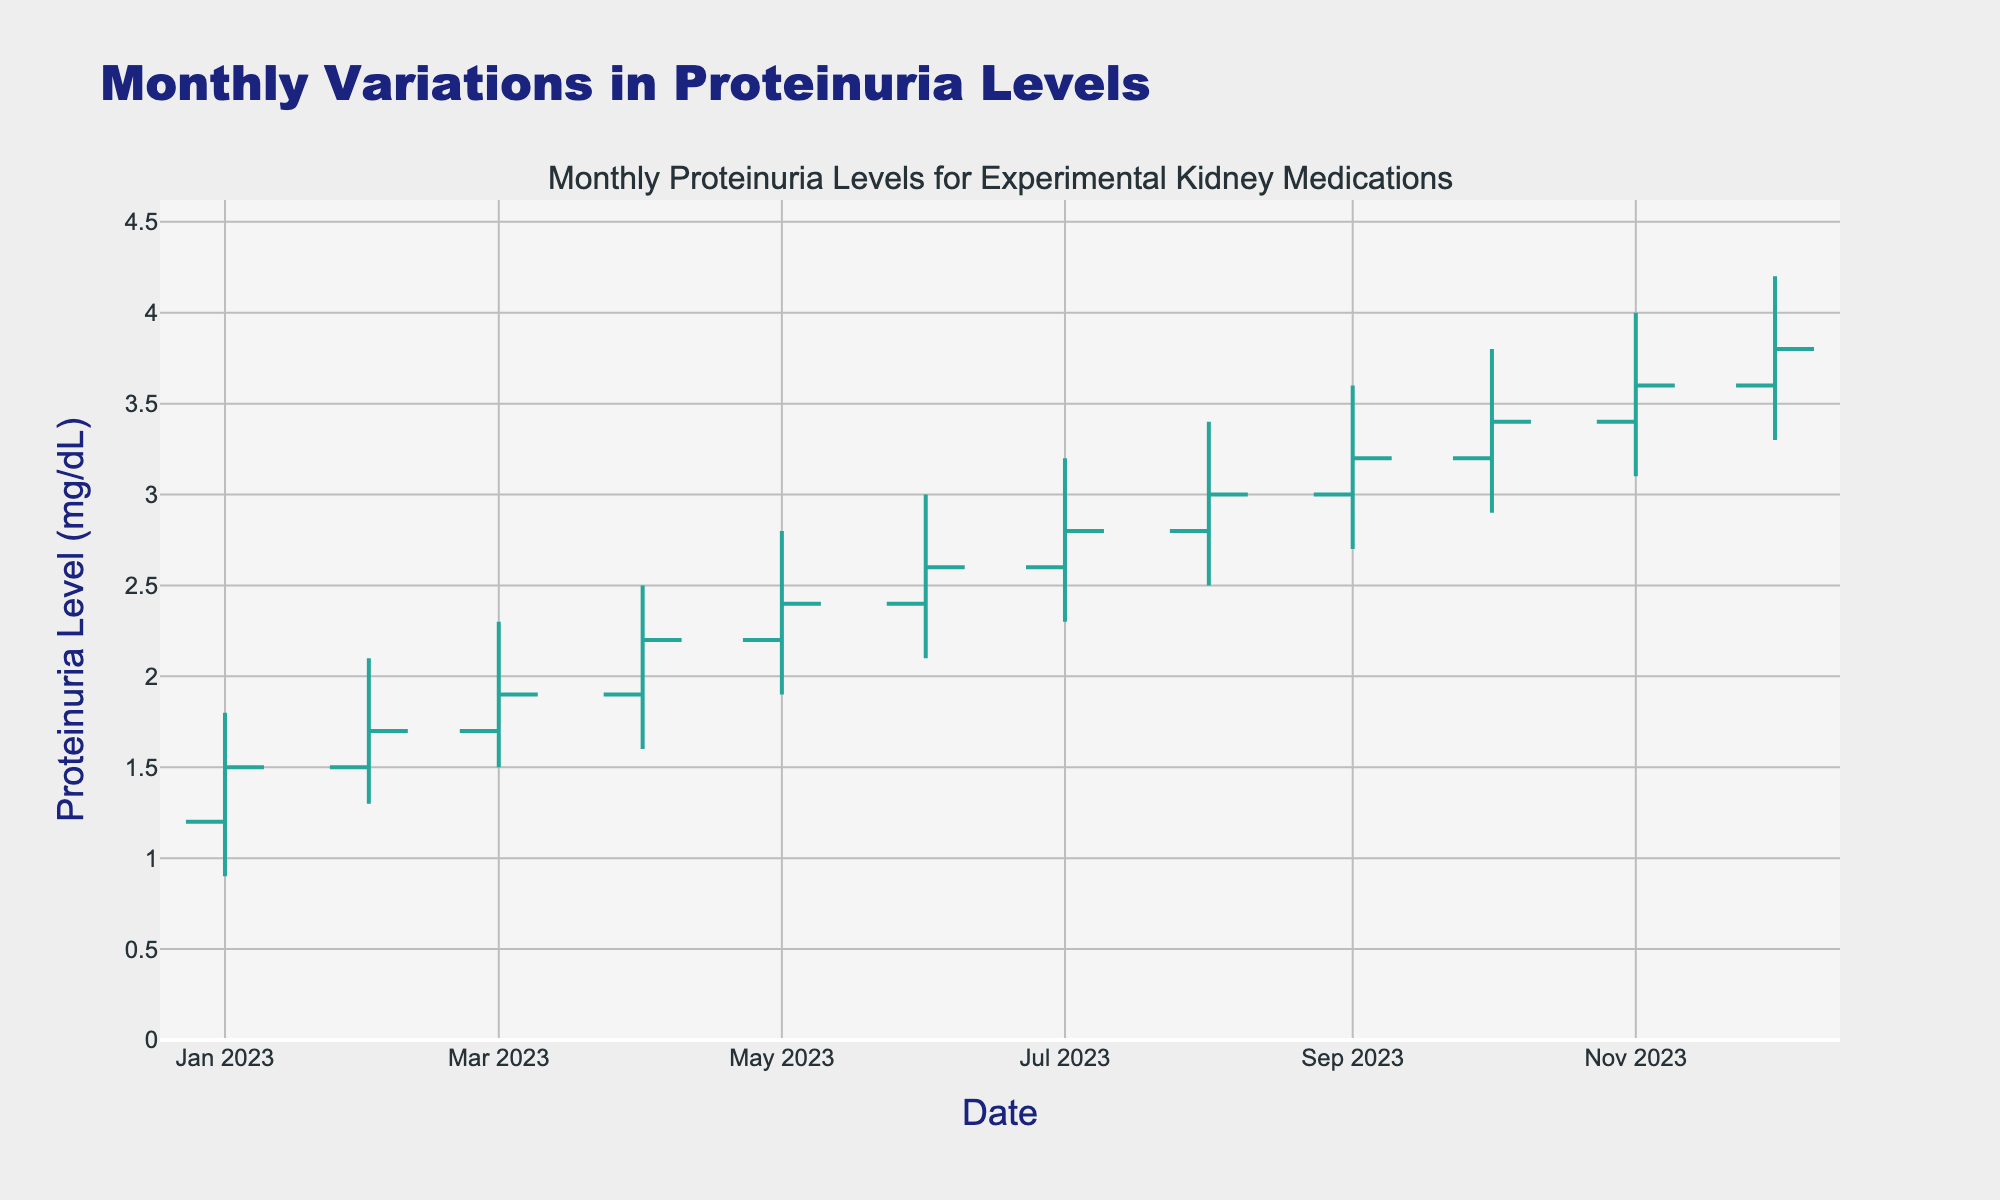What's the title of the chart? The title is prominently displayed at the top of the chart, summarizing the overall content being visualized. In this case, it is "Monthly Variations in Proteinuria Levels."
Answer: Monthly Variations in Proteinuria Levels What do the x-axis and y-axis represent? The x-axis shows time in months for the year 2023, while the y-axis represents the proteinuria levels in mg/dL.
Answer: x-axis: Date, y-axis: Proteinuria Level (mg/dL) What was the highest proteinuria level recorded in 2023? The highest level can be found by looking at the 'High' values in the data. The maximum value of these is 4.2 mg/dL, recorded in December.
Answer: 4.2 mg/dL Which month had the smallest range of proteinuria levels? The range can be calculated by subtracting the 'Low' value from the 'High' value for each month. The smallest range is January with 0.9 mg/dL (1.8 - 0.9).
Answer: January Which month showed the greatest increase in proteinuria levels from open to close? You can find this by calculating the difference between 'Close' and 'Open' for each month. The greatest increase is in January with a difference of 0.3 mg/dL (1.5 - 1.2).
Answer: January How did the proteinuria levels trend from January to December? Observing the 'Close' values from January to December shows a steady increase in proteinuria levels throughout the year, starting at 1.5 mg/dL in January and ending at 3.8 mg/dL in December.
Answer: Increasing During which months did the proteinuria levels never fall below 1.5 mg/dL? By looking at the 'Low' values, if they are all greater than or equal to 1.5 mg/dL, that qualifies. This is true for May to December.
Answer: May to December Which two months had the same closing proteinuria level? Comparing 'Close' values reveals that February (1.7 mg/dL) and March (1.7 mg/dL) had the same closing proteinuria levels.
Answer: February and March Was there any month where the closing value was lower than the opening value? Observing the 'Close' and 'Open' columns, if 'Close' is less than 'Open', this condition holds. The data shows no such instances, as every month's closing value is higher than or equal to its opening value.
Answer: No What's the average high proteinuria level for the last three months of the year? Summing the 'High' values for October, November, and December (3.8, 4.0, 4.2) and then dividing by 3. (3.8 + 4.0 + 4.2) / 3 = 4.0 mg/dL.
Answer: 4.0 mg/dL 